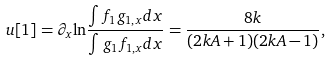<formula> <loc_0><loc_0><loc_500><loc_500>u [ 1 ] = \partial _ { x } { \ln } \frac { \int f _ { 1 } g _ { 1 , x } { d } x } { \int g _ { 1 } f _ { 1 , x } { d } x } = \frac { 8 k } { ( 2 k A + 1 ) ( 2 k A - 1 ) } ,</formula> 